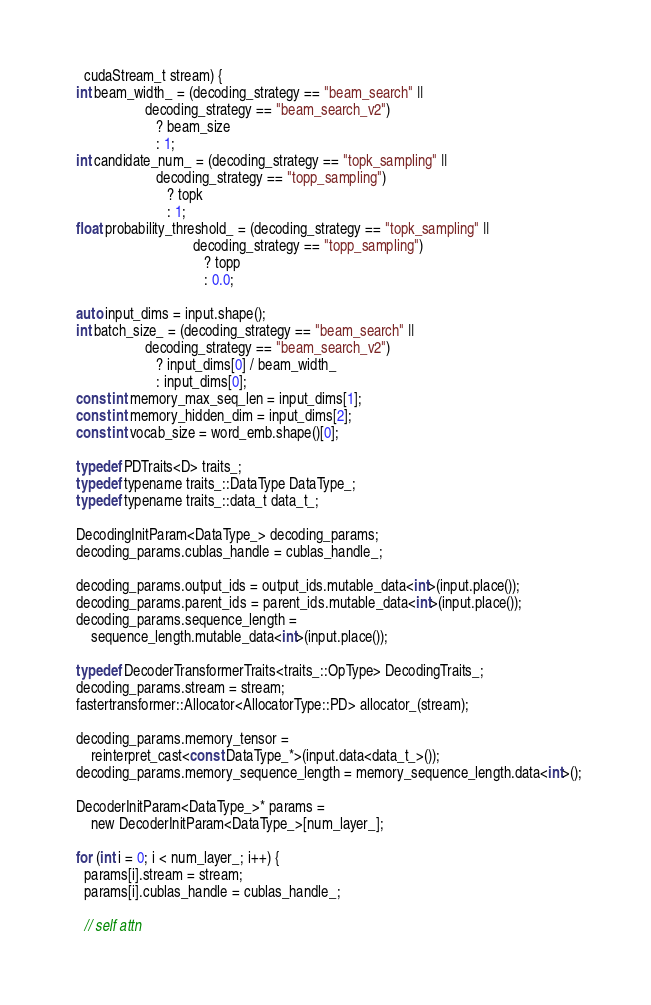<code> <loc_0><loc_0><loc_500><loc_500><_Cuda_>    cudaStream_t stream) {
  int beam_width_ = (decoding_strategy == "beam_search" ||
                     decoding_strategy == "beam_search_v2")
                        ? beam_size
                        : 1;
  int candidate_num_ = (decoding_strategy == "topk_sampling" ||
                        decoding_strategy == "topp_sampling")
                           ? topk
                           : 1;
  float probability_threshold_ = (decoding_strategy == "topk_sampling" ||
                                  decoding_strategy == "topp_sampling")
                                     ? topp
                                     : 0.0;

  auto input_dims = input.shape();
  int batch_size_ = (decoding_strategy == "beam_search" ||
                     decoding_strategy == "beam_search_v2")
                        ? input_dims[0] / beam_width_
                        : input_dims[0];
  const int memory_max_seq_len = input_dims[1];
  const int memory_hidden_dim = input_dims[2];
  const int vocab_size = word_emb.shape()[0];

  typedef PDTraits<D> traits_;
  typedef typename traits_::DataType DataType_;
  typedef typename traits_::data_t data_t_;

  DecodingInitParam<DataType_> decoding_params;
  decoding_params.cublas_handle = cublas_handle_;

  decoding_params.output_ids = output_ids.mutable_data<int>(input.place());
  decoding_params.parent_ids = parent_ids.mutable_data<int>(input.place());
  decoding_params.sequence_length =
      sequence_length.mutable_data<int>(input.place());

  typedef DecoderTransformerTraits<traits_::OpType> DecodingTraits_;
  decoding_params.stream = stream;
  fastertransformer::Allocator<AllocatorType::PD> allocator_(stream);

  decoding_params.memory_tensor =
      reinterpret_cast<const DataType_*>(input.data<data_t_>());
  decoding_params.memory_sequence_length = memory_sequence_length.data<int>();

  DecoderInitParam<DataType_>* params =
      new DecoderInitParam<DataType_>[num_layer_];

  for (int i = 0; i < num_layer_; i++) {
    params[i].stream = stream;
    params[i].cublas_handle = cublas_handle_;

    // self attn</code> 